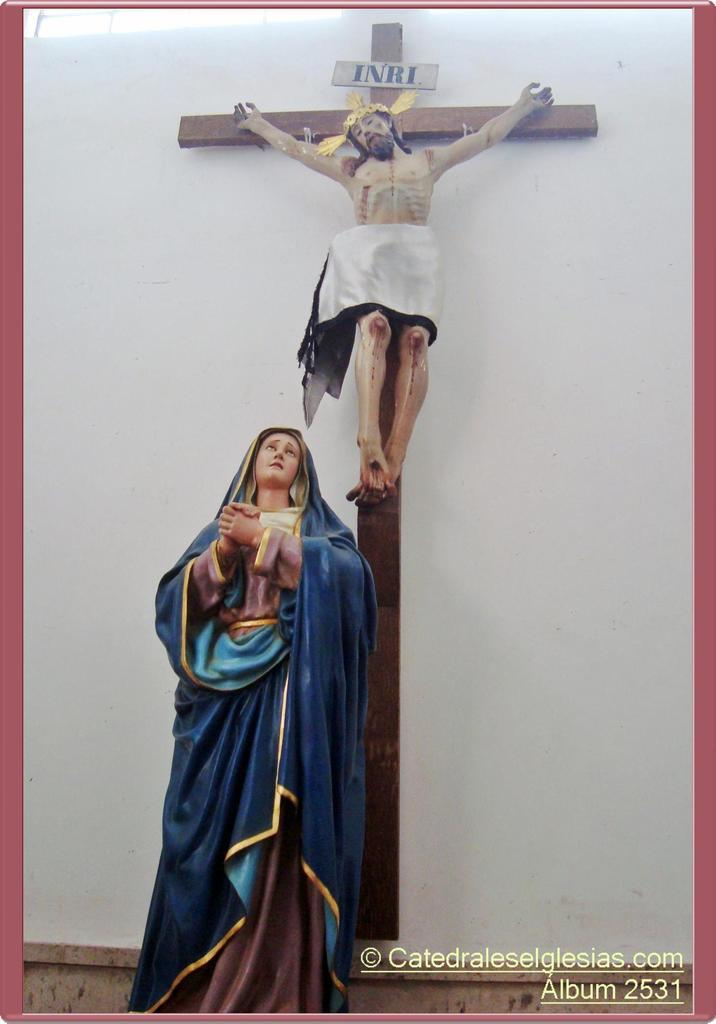How many statues are present in the image? There are two statues in the image. Can you describe the statues in terms of gender? One statue is of a man, and the other statue is of a woman. What type of wood is used to create the fairies in the image? There are no fairies present in the image; the statues are of a man and a woman. 